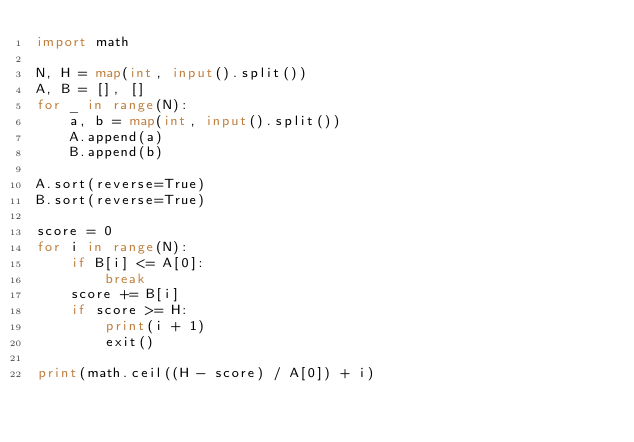Convert code to text. <code><loc_0><loc_0><loc_500><loc_500><_Python_>import math

N, H = map(int, input().split())
A, B = [], []
for _ in range(N):
    a, b = map(int, input().split())
    A.append(a)
    B.append(b)

A.sort(reverse=True)
B.sort(reverse=True)

score = 0
for i in range(N):
    if B[i] <= A[0]:
        break
    score += B[i]
    if score >= H:
        print(i + 1)
        exit()

print(math.ceil((H - score) / A[0]) + i)
</code> 